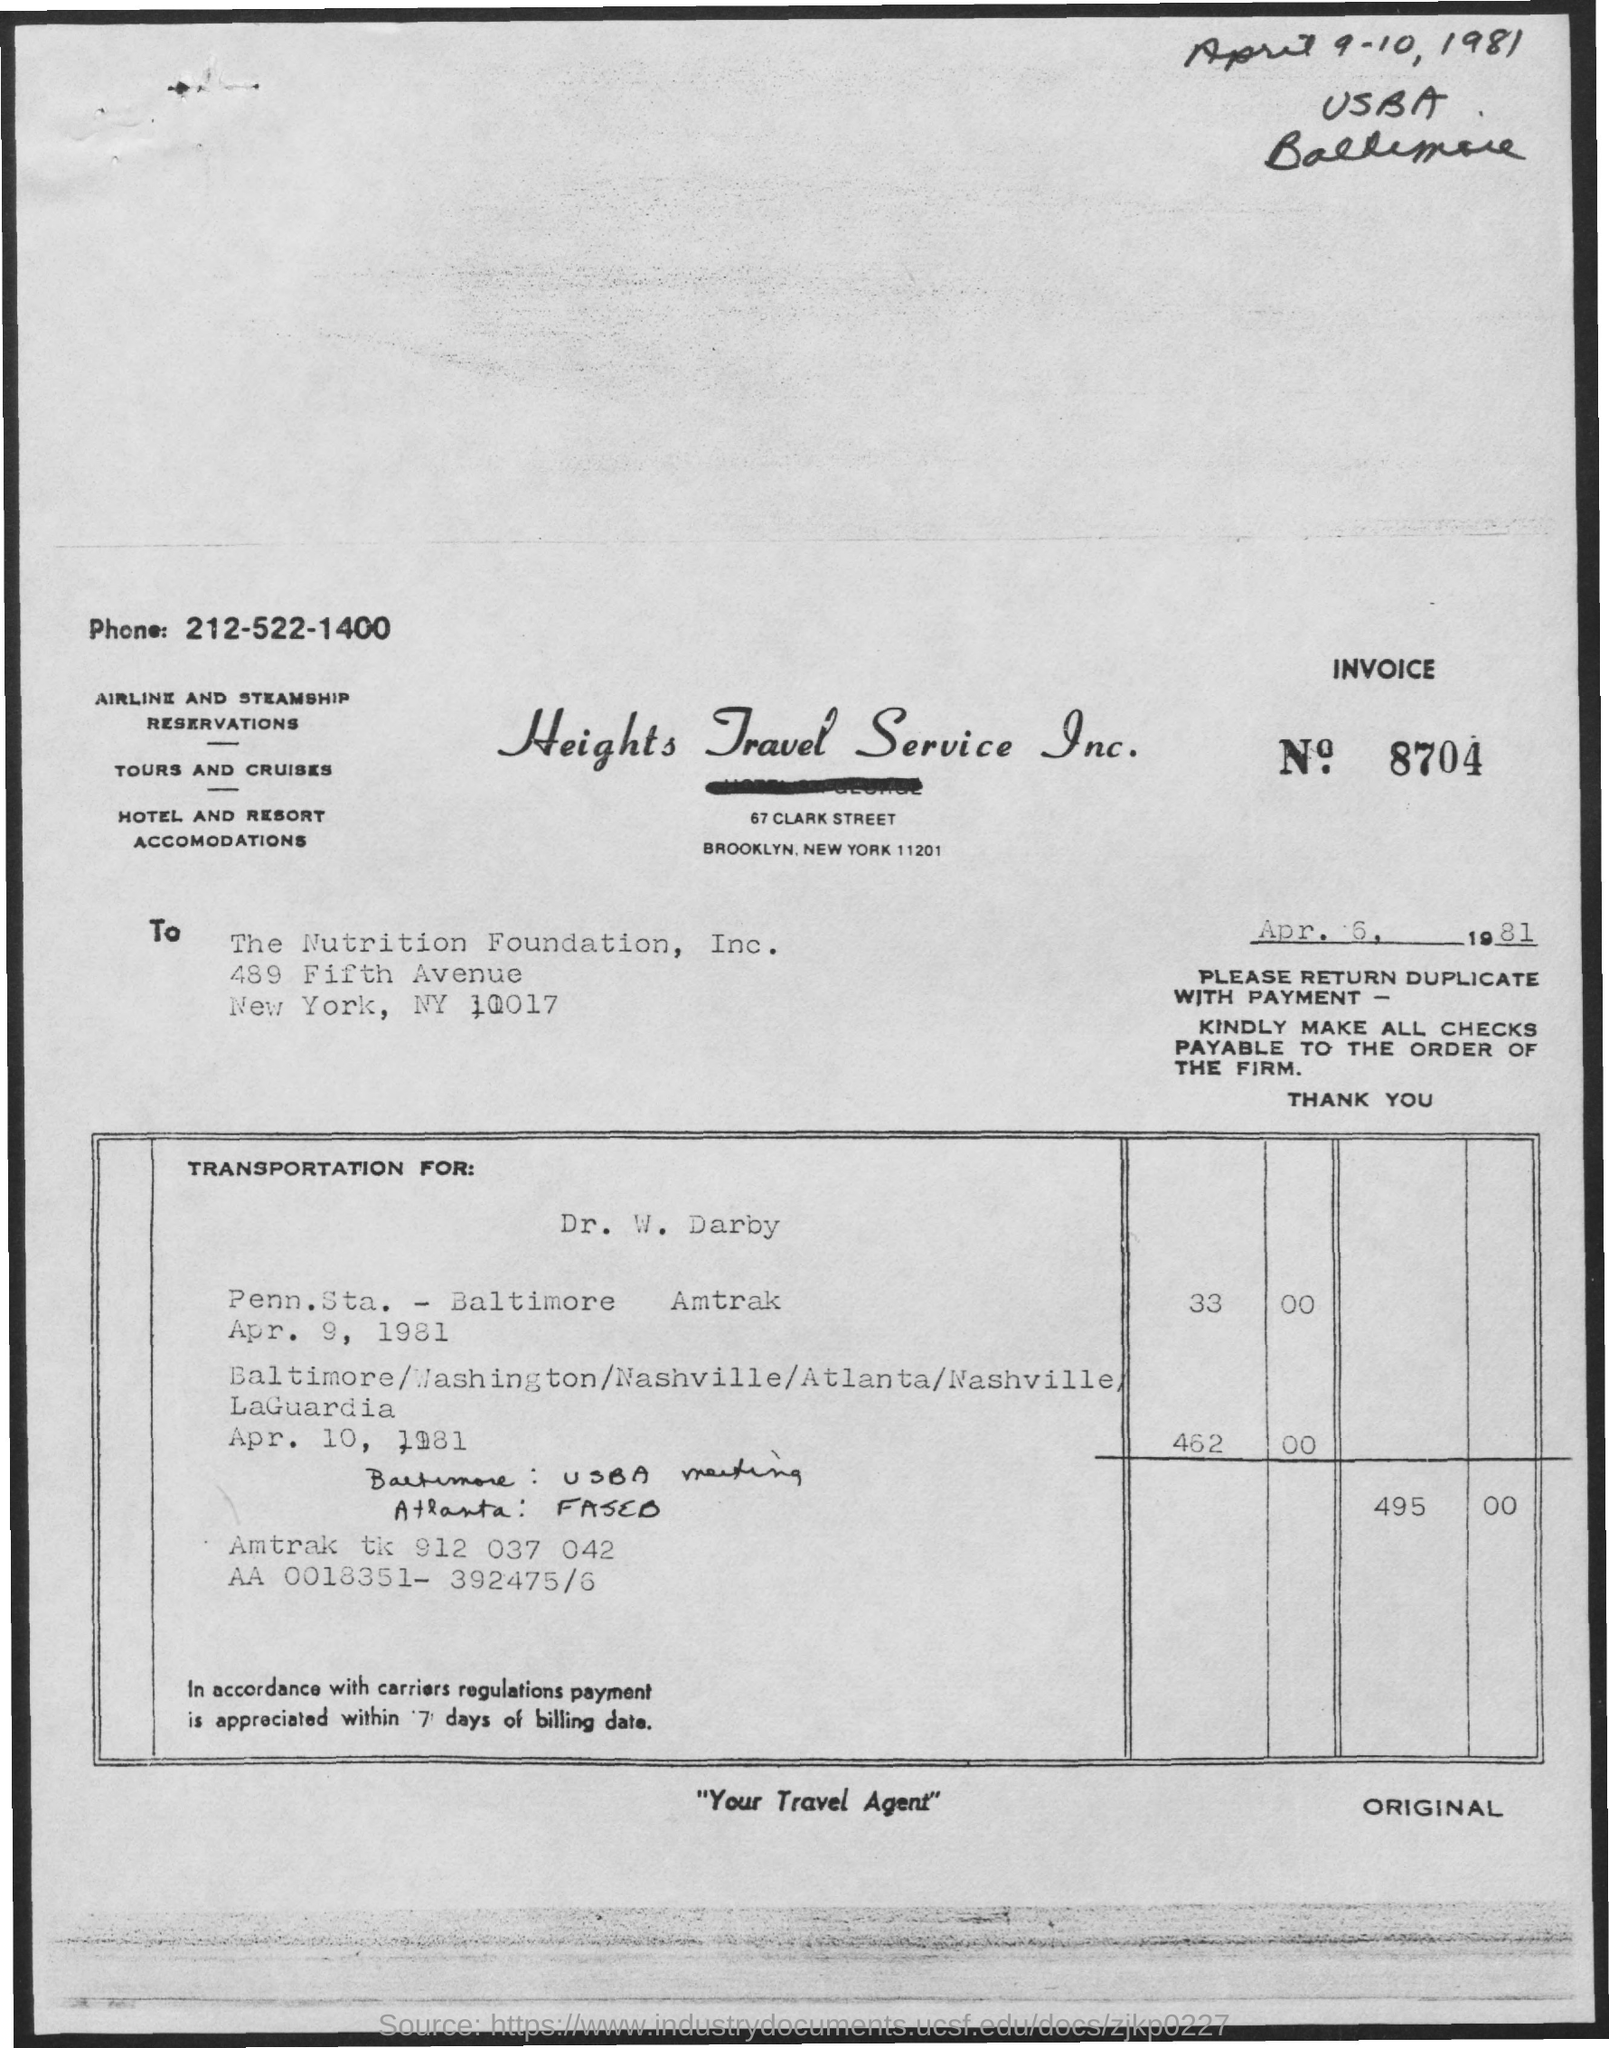What is the INVOICE number ?
Ensure brevity in your answer.  8704. What is the Telephone Number?
Offer a terse response. 212-522-1400. What is the company name ?
Your answer should be compact. Heights Travel Service Inc. Who is the Memorandum Addressed to ?
Your answer should be compact. THE NUTRITION FOUNDATION, INC. 